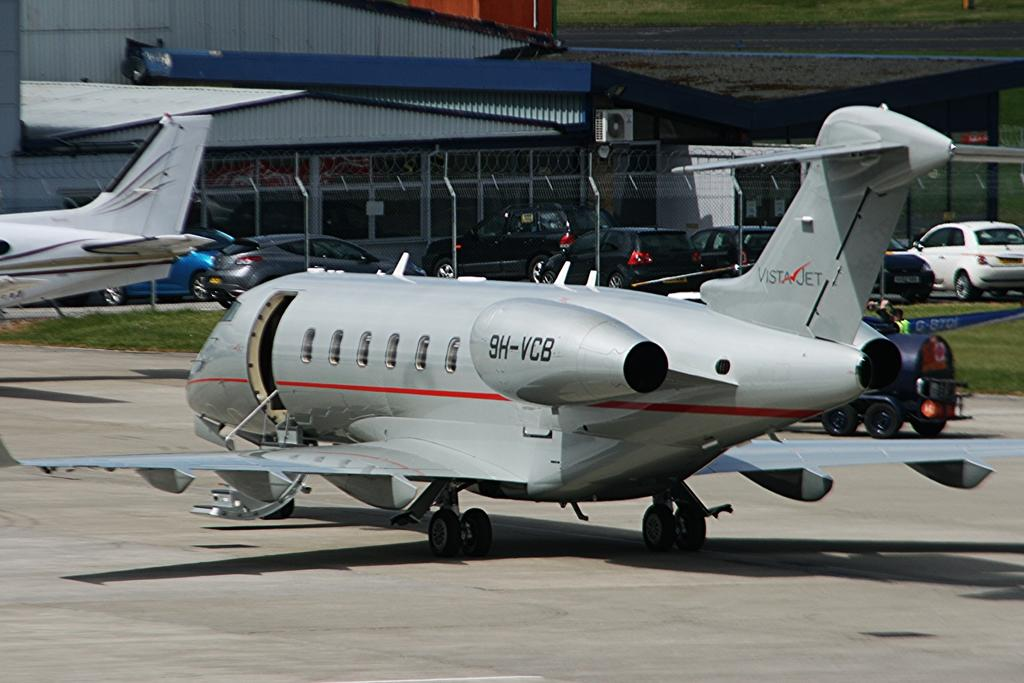<image>
Give a short and clear explanation of the subsequent image. A Vista Jet sitting on the tarmac has 9H-VCB written on the engine 